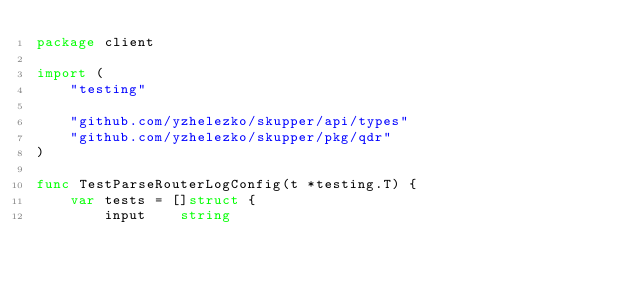Convert code to text. <code><loc_0><loc_0><loc_500><loc_500><_Go_>package client

import (
	"testing"

	"github.com/yzhelezko/skupper/api/types"
	"github.com/yzhelezko/skupper/pkg/qdr"
)

func TestParseRouterLogConfig(t *testing.T) {
	var tests = []struct {
		input    string</code> 